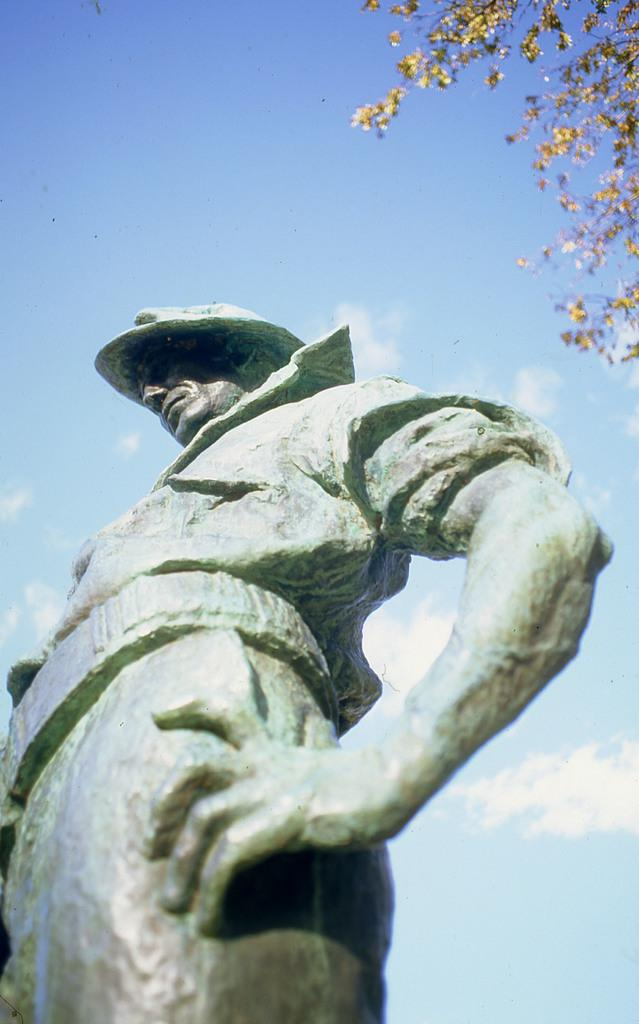What is the main subject in the image? There is a statue in the image. What can be seen in the background of the image? There is a plant in the background of the image. What is the color of the plant? The plant is green. What is visible above the statue and plant in the image? The sky is visible in the image. What are the colors of the sky in the image? The sky is blue and white in color. How many goldfish are swimming in the statue's reflection in the image? There are no goldfish present in the image, and the statue does not have a reflection. 